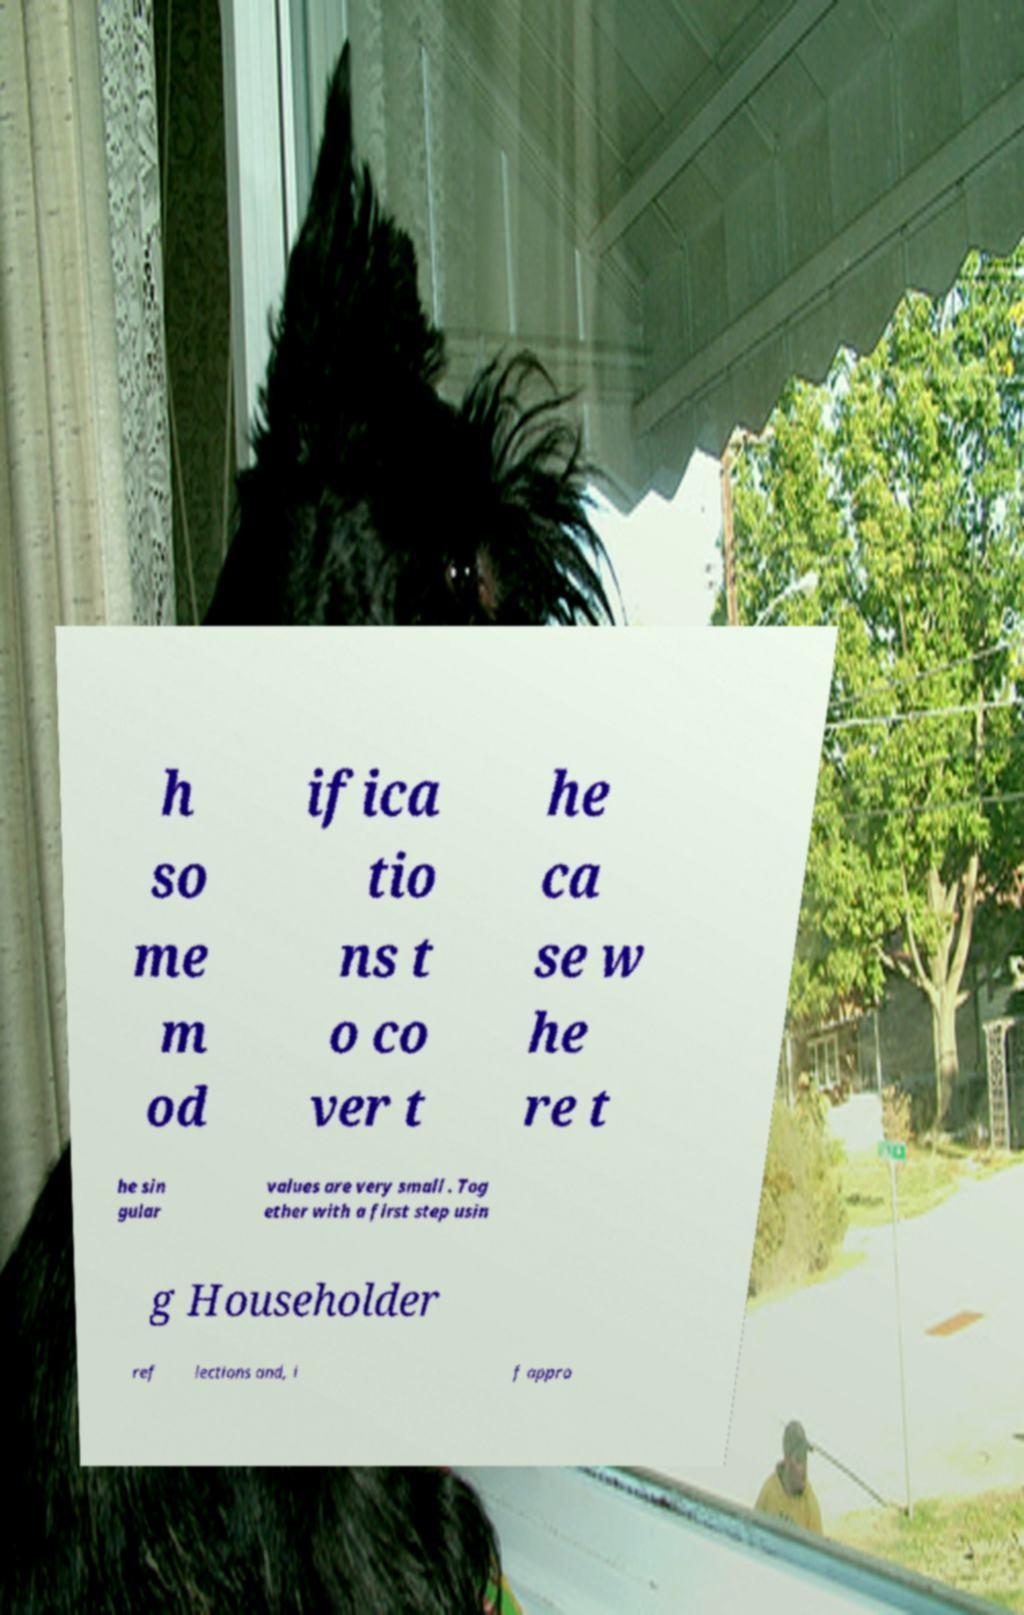Can you read and provide the text displayed in the image?This photo seems to have some interesting text. Can you extract and type it out for me? h so me m od ifica tio ns t o co ver t he ca se w he re t he sin gular values are very small . Tog ether with a first step usin g Householder ref lections and, i f appro 